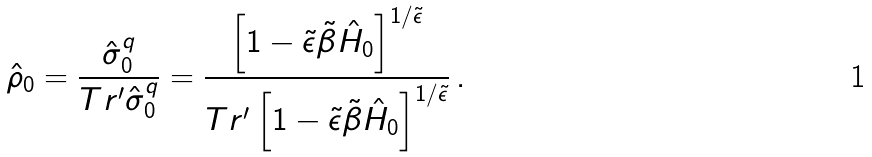<formula> <loc_0><loc_0><loc_500><loc_500>\hat { \rho } _ { 0 } = \frac { \hat { \sigma } ^ { q } _ { 0 } } { T r ^ { \prime } \hat { \sigma } _ { 0 } ^ { q } } = \frac { \left [ 1 - \tilde { \epsilon } \tilde { \beta } \hat { H } _ { 0 } \right ] ^ { 1 / \tilde { \epsilon } } } { T r ^ { \prime } \left [ 1 - \tilde { \epsilon } \tilde { \beta } \hat { H } _ { 0 } \right ] ^ { 1 / \tilde { \epsilon } } } \, .</formula> 